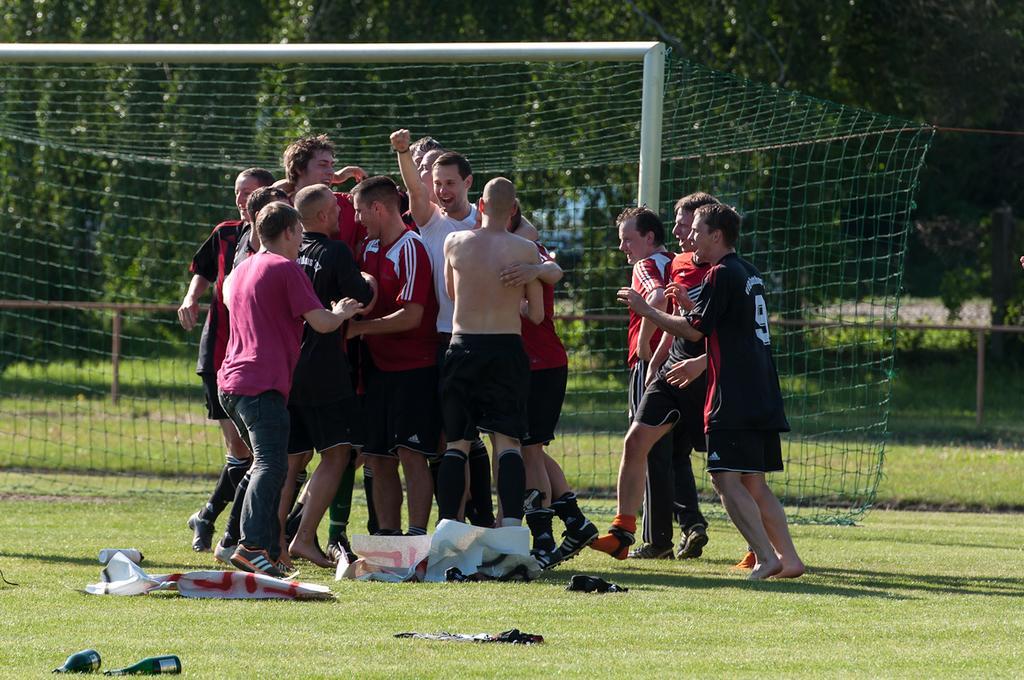Describe this image in one or two sentences. In the middle of this image, there are persons in different color shorts, celebrating on the ground, on which there is grass, there are banners, bottles and clothes. In the background, there is a net, there are trees, plants and grass on the ground. 